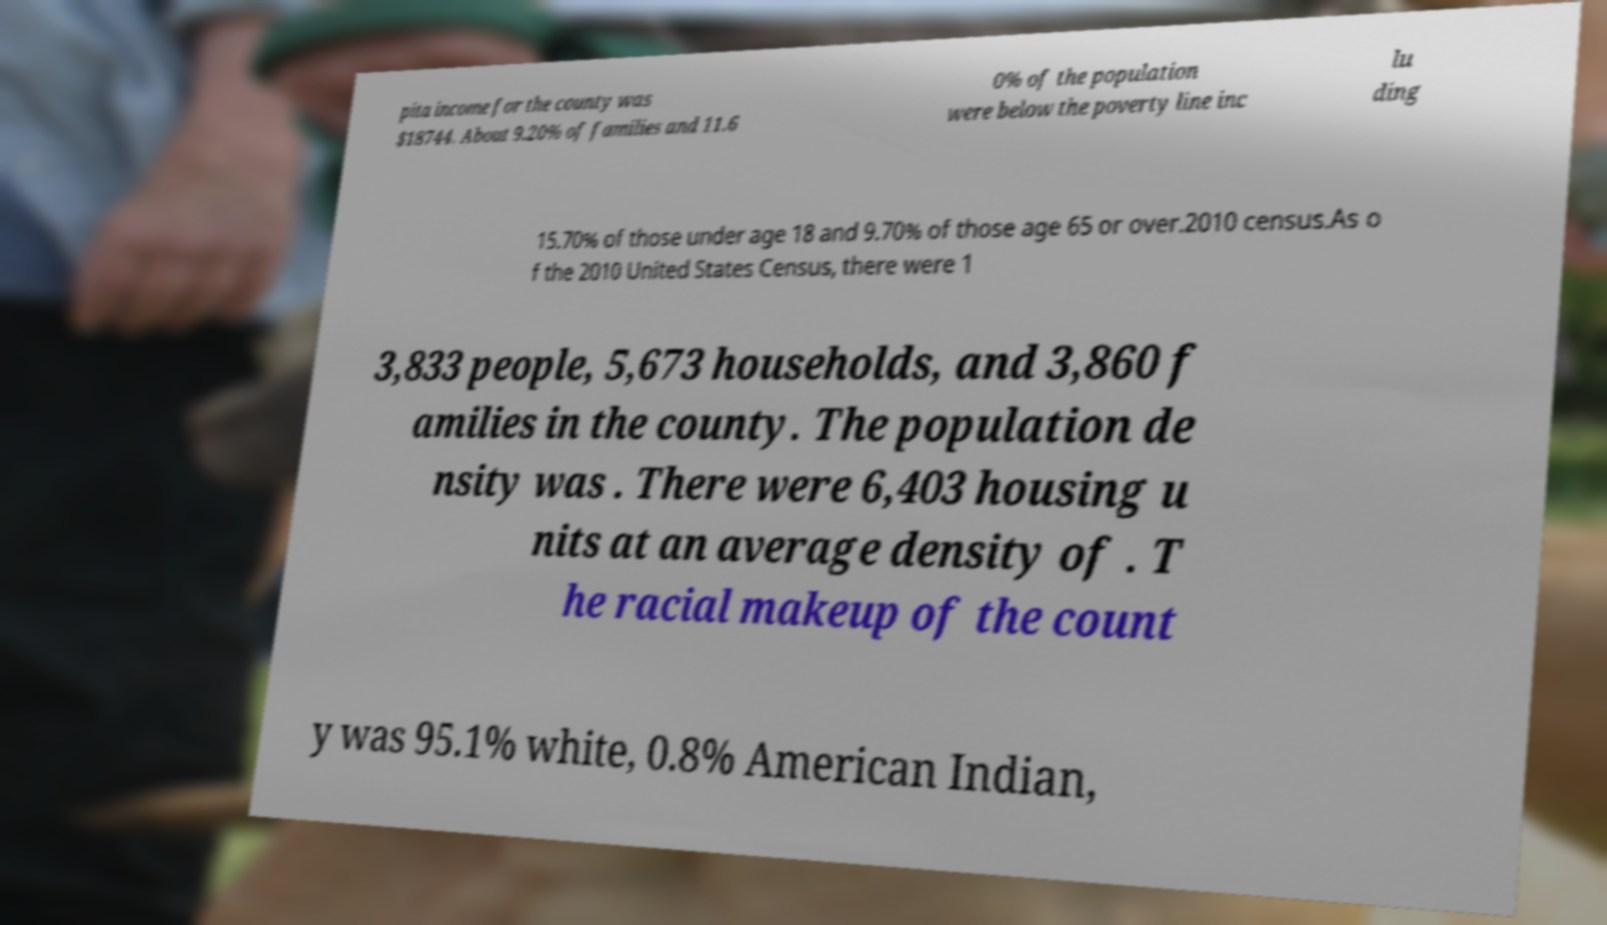Could you extract and type out the text from this image? pita income for the county was $18744. About 9.20% of families and 11.6 0% of the population were below the poverty line inc lu ding 15.70% of those under age 18 and 9.70% of those age 65 or over.2010 census.As o f the 2010 United States Census, there were 1 3,833 people, 5,673 households, and 3,860 f amilies in the county. The population de nsity was . There were 6,403 housing u nits at an average density of . T he racial makeup of the count y was 95.1% white, 0.8% American Indian, 